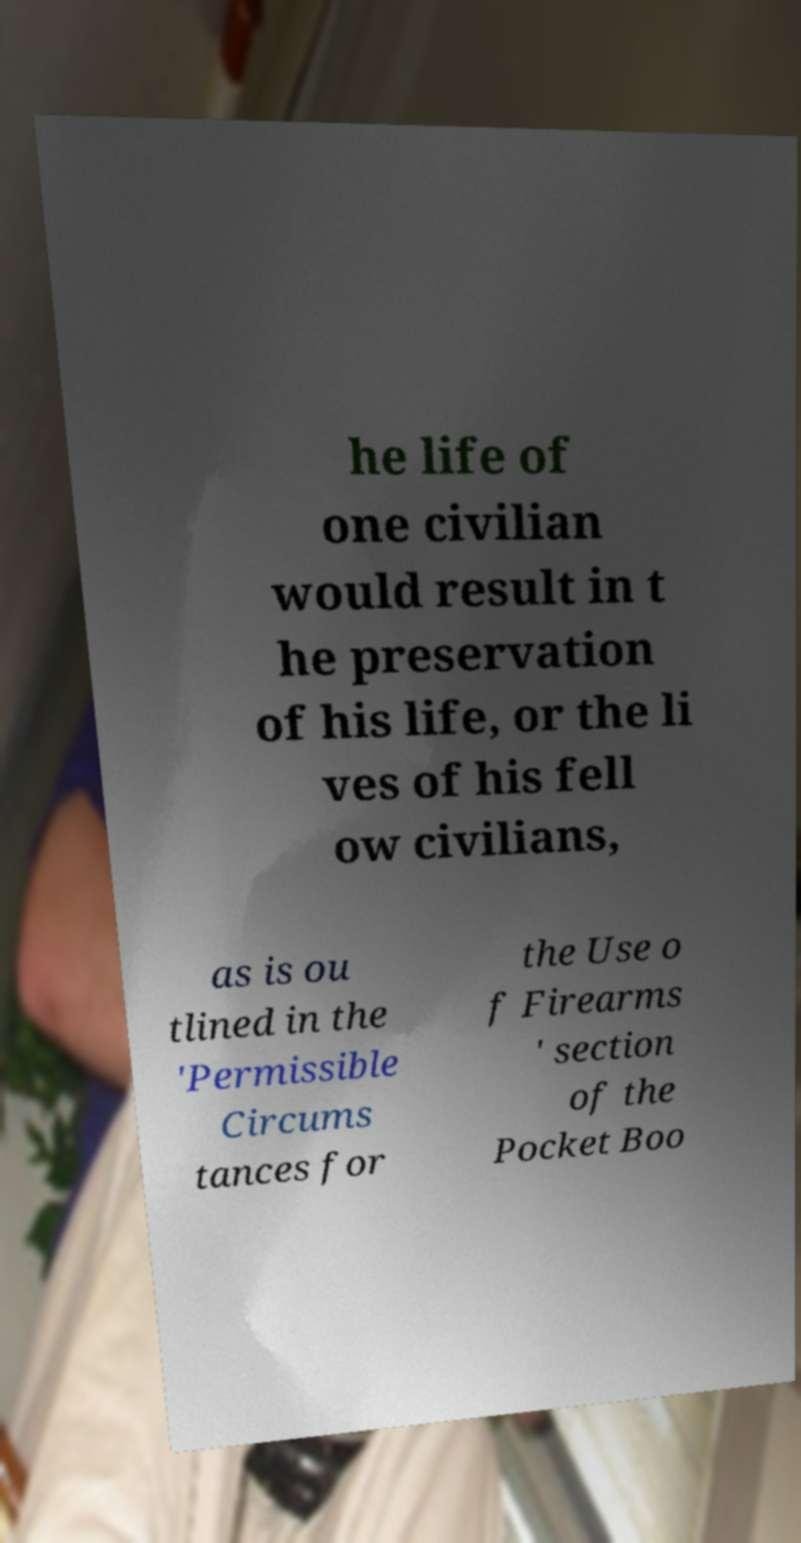I need the written content from this picture converted into text. Can you do that? he life of one civilian would result in t he preservation of his life, or the li ves of his fell ow civilians, as is ou tlined in the 'Permissible Circums tances for the Use o f Firearms ' section of the Pocket Boo 